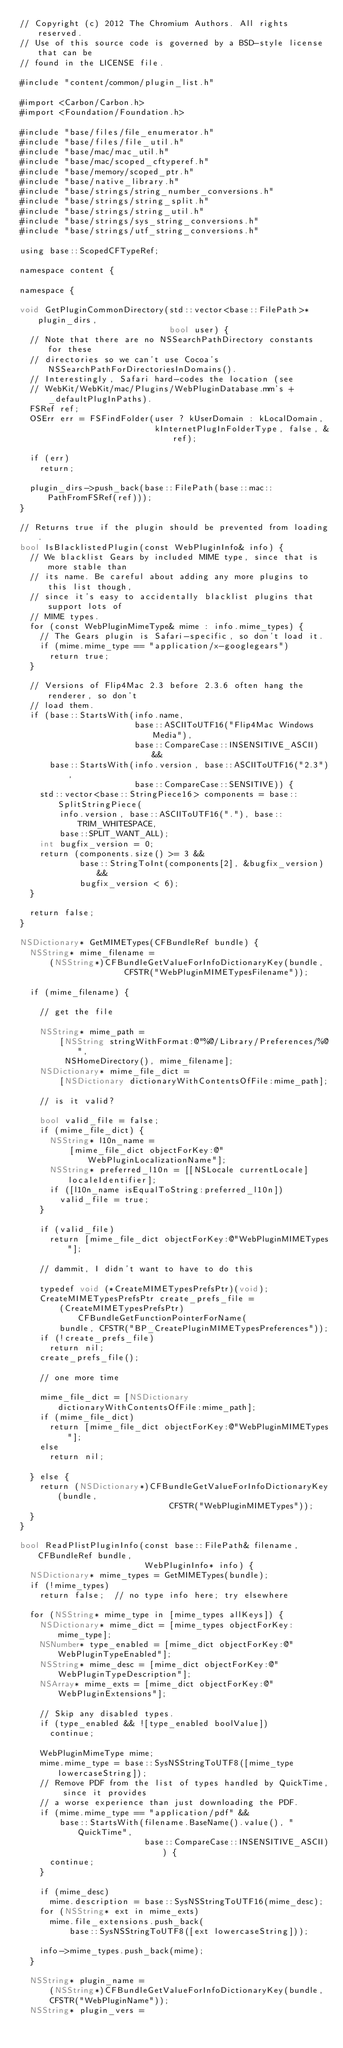Convert code to text. <code><loc_0><loc_0><loc_500><loc_500><_ObjectiveC_>// Copyright (c) 2012 The Chromium Authors. All rights reserved.
// Use of this source code is governed by a BSD-style license that can be
// found in the LICENSE file.

#include "content/common/plugin_list.h"

#import <Carbon/Carbon.h>
#import <Foundation/Foundation.h>

#include "base/files/file_enumerator.h"
#include "base/files/file_util.h"
#include "base/mac/mac_util.h"
#include "base/mac/scoped_cftyperef.h"
#include "base/memory/scoped_ptr.h"
#include "base/native_library.h"
#include "base/strings/string_number_conversions.h"
#include "base/strings/string_split.h"
#include "base/strings/string_util.h"
#include "base/strings/sys_string_conversions.h"
#include "base/strings/utf_string_conversions.h"

using base::ScopedCFTypeRef;

namespace content {

namespace {

void GetPluginCommonDirectory(std::vector<base::FilePath>* plugin_dirs,
                              bool user) {
  // Note that there are no NSSearchPathDirectory constants for these
  // directories so we can't use Cocoa's NSSearchPathForDirectoriesInDomains().
  // Interestingly, Safari hard-codes the location (see
  // WebKit/WebKit/mac/Plugins/WebPluginDatabase.mm's +_defaultPlugInPaths).
  FSRef ref;
  OSErr err = FSFindFolder(user ? kUserDomain : kLocalDomain,
                           kInternetPlugInFolderType, false, &ref);

  if (err)
    return;

  plugin_dirs->push_back(base::FilePath(base::mac::PathFromFSRef(ref)));
}

// Returns true if the plugin should be prevented from loading.
bool IsBlacklistedPlugin(const WebPluginInfo& info) {
  // We blacklist Gears by included MIME type, since that is more stable than
  // its name. Be careful about adding any more plugins to this list though,
  // since it's easy to accidentally blacklist plugins that support lots of
  // MIME types.
  for (const WebPluginMimeType& mime : info.mime_types) {
    // The Gears plugin is Safari-specific, so don't load it.
    if (mime.mime_type == "application/x-googlegears")
      return true;
  }

  // Versions of Flip4Mac 2.3 before 2.3.6 often hang the renderer, so don't
  // load them.
  if (base::StartsWith(info.name,
                       base::ASCIIToUTF16("Flip4Mac Windows Media"),
                       base::CompareCase::INSENSITIVE_ASCII) &&
      base::StartsWith(info.version, base::ASCIIToUTF16("2.3"),
                       base::CompareCase::SENSITIVE)) {
    std::vector<base::StringPiece16> components = base::SplitStringPiece(
        info.version, base::ASCIIToUTF16("."), base::TRIM_WHITESPACE,
        base::SPLIT_WANT_ALL);
    int bugfix_version = 0;
    return (components.size() >= 3 &&
            base::StringToInt(components[2], &bugfix_version) &&
            bugfix_version < 6);
  }

  return false;
}

NSDictionary* GetMIMETypes(CFBundleRef bundle) {
  NSString* mime_filename =
      (NSString*)CFBundleGetValueForInfoDictionaryKey(bundle,
                     CFSTR("WebPluginMIMETypesFilename"));

  if (mime_filename) {

    // get the file

    NSString* mime_path =
        [NSString stringWithFormat:@"%@/Library/Preferences/%@",
         NSHomeDirectory(), mime_filename];
    NSDictionary* mime_file_dict =
        [NSDictionary dictionaryWithContentsOfFile:mime_path];

    // is it valid?

    bool valid_file = false;
    if (mime_file_dict) {
      NSString* l10n_name =
          [mime_file_dict objectForKey:@"WebPluginLocalizationName"];
      NSString* preferred_l10n = [[NSLocale currentLocale] localeIdentifier];
      if ([l10n_name isEqualToString:preferred_l10n])
        valid_file = true;
    }

    if (valid_file)
      return [mime_file_dict objectForKey:@"WebPluginMIMETypes"];

    // dammit, I didn't want to have to do this

    typedef void (*CreateMIMETypesPrefsPtr)(void);
    CreateMIMETypesPrefsPtr create_prefs_file =
        (CreateMIMETypesPrefsPtr)CFBundleGetFunctionPointerForName(
        bundle, CFSTR("BP_CreatePluginMIMETypesPreferences"));
    if (!create_prefs_file)
      return nil;
    create_prefs_file();

    // one more time

    mime_file_dict = [NSDictionary dictionaryWithContentsOfFile:mime_path];
    if (mime_file_dict)
      return [mime_file_dict objectForKey:@"WebPluginMIMETypes"];
    else
      return nil;

  } else {
    return (NSDictionary*)CFBundleGetValueForInfoDictionaryKey(bundle,
                              CFSTR("WebPluginMIMETypes"));
  }
}

bool ReadPlistPluginInfo(const base::FilePath& filename, CFBundleRef bundle,
                         WebPluginInfo* info) {
  NSDictionary* mime_types = GetMIMETypes(bundle);
  if (!mime_types)
    return false;  // no type info here; try elsewhere

  for (NSString* mime_type in [mime_types allKeys]) {
    NSDictionary* mime_dict = [mime_types objectForKey:mime_type];
    NSNumber* type_enabled = [mime_dict objectForKey:@"WebPluginTypeEnabled"];
    NSString* mime_desc = [mime_dict objectForKey:@"WebPluginTypeDescription"];
    NSArray* mime_exts = [mime_dict objectForKey:@"WebPluginExtensions"];

    // Skip any disabled types.
    if (type_enabled && ![type_enabled boolValue])
      continue;

    WebPluginMimeType mime;
    mime.mime_type = base::SysNSStringToUTF8([mime_type lowercaseString]);
    // Remove PDF from the list of types handled by QuickTime, since it provides
    // a worse experience than just downloading the PDF.
    if (mime.mime_type == "application/pdf" &&
        base::StartsWith(filename.BaseName().value(), "QuickTime",
                         base::CompareCase::INSENSITIVE_ASCII)) {
      continue;
    }

    if (mime_desc)
      mime.description = base::SysNSStringToUTF16(mime_desc);
    for (NSString* ext in mime_exts)
      mime.file_extensions.push_back(
          base::SysNSStringToUTF8([ext lowercaseString]));

    info->mime_types.push_back(mime);
  }

  NSString* plugin_name =
      (NSString*)CFBundleGetValueForInfoDictionaryKey(bundle,
      CFSTR("WebPluginName"));
  NSString* plugin_vers =</code> 